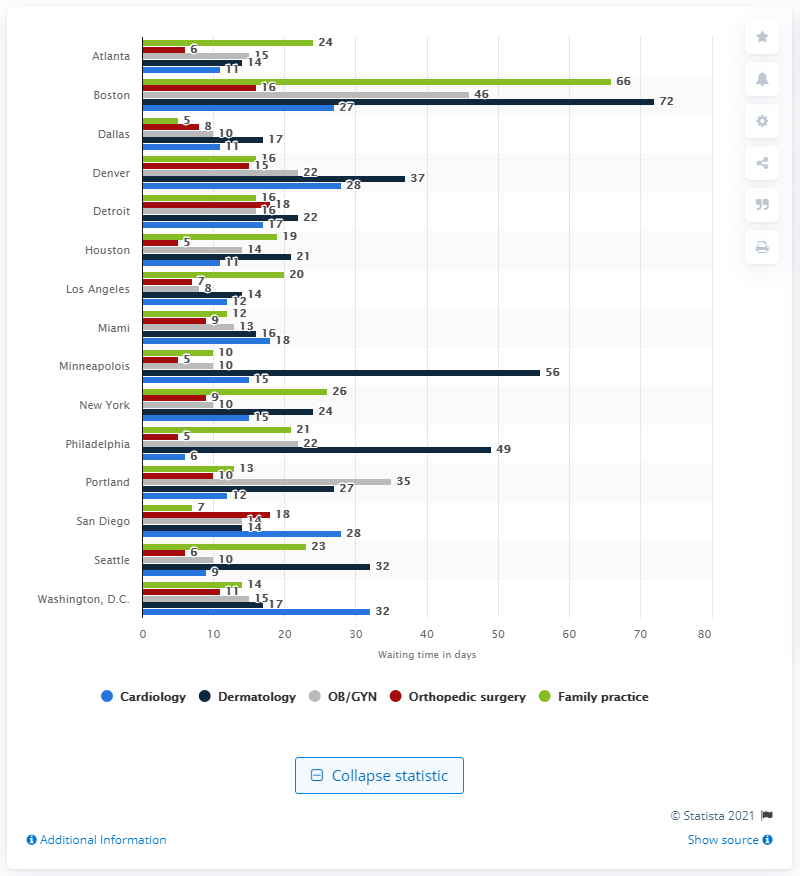Specify some key components in this picture. Boston has one of the highest average wait times for a physician appointment. 